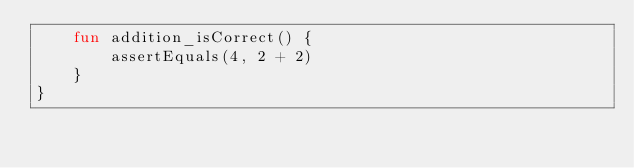Convert code to text. <code><loc_0><loc_0><loc_500><loc_500><_Kotlin_>    fun addition_isCorrect() {
        assertEquals(4, 2 + 2)
    }
}</code> 